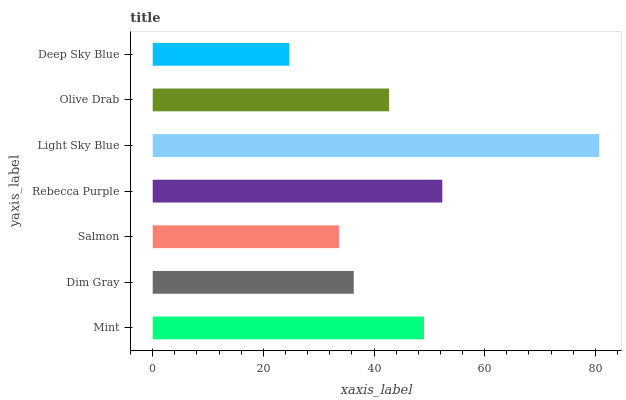Is Deep Sky Blue the minimum?
Answer yes or no. Yes. Is Light Sky Blue the maximum?
Answer yes or no. Yes. Is Dim Gray the minimum?
Answer yes or no. No. Is Dim Gray the maximum?
Answer yes or no. No. Is Mint greater than Dim Gray?
Answer yes or no. Yes. Is Dim Gray less than Mint?
Answer yes or no. Yes. Is Dim Gray greater than Mint?
Answer yes or no. No. Is Mint less than Dim Gray?
Answer yes or no. No. Is Olive Drab the high median?
Answer yes or no. Yes. Is Olive Drab the low median?
Answer yes or no. Yes. Is Light Sky Blue the high median?
Answer yes or no. No. Is Light Sky Blue the low median?
Answer yes or no. No. 